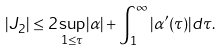Convert formula to latex. <formula><loc_0><loc_0><loc_500><loc_500>| J _ { 2 } | \leq 2 \, \underset { 1 \leq \tau } { \sup } | \alpha | + \int _ { 1 } ^ { \infty } | \alpha ^ { \prime } ( \tau ) | d \tau .</formula> 